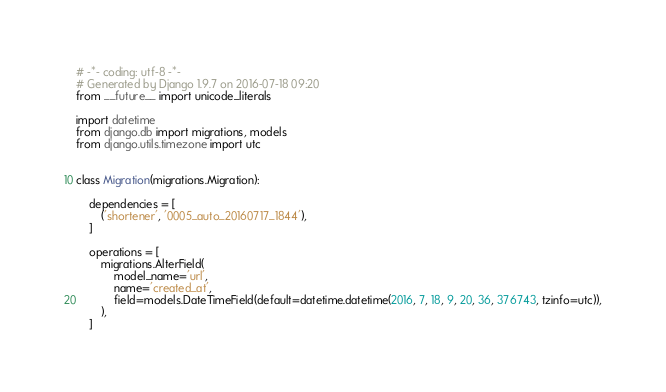<code> <loc_0><loc_0><loc_500><loc_500><_Python_># -*- coding: utf-8 -*-
# Generated by Django 1.9.7 on 2016-07-18 09:20
from __future__ import unicode_literals

import datetime
from django.db import migrations, models
from django.utils.timezone import utc


class Migration(migrations.Migration):

    dependencies = [
        ('shortener', '0005_auto_20160717_1844'),
    ]

    operations = [
        migrations.AlterField(
            model_name='url',
            name='created_at',
            field=models.DateTimeField(default=datetime.datetime(2016, 7, 18, 9, 20, 36, 376743, tzinfo=utc)),
        ),
    ]
</code> 